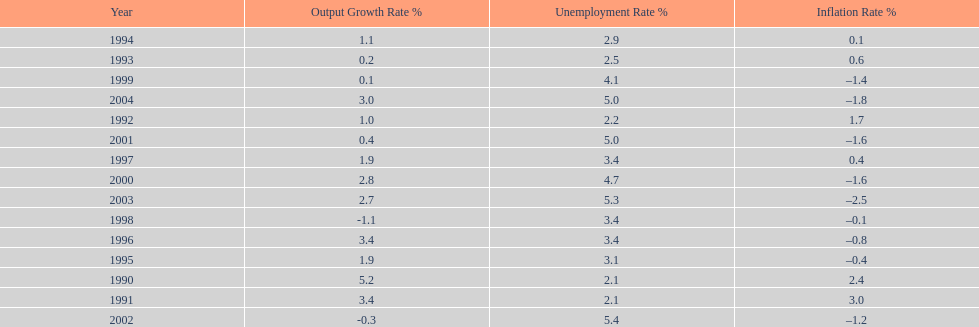In what years, between 1990 and 2004, did japan's unemployment rate reach 5% or higher? 4. 